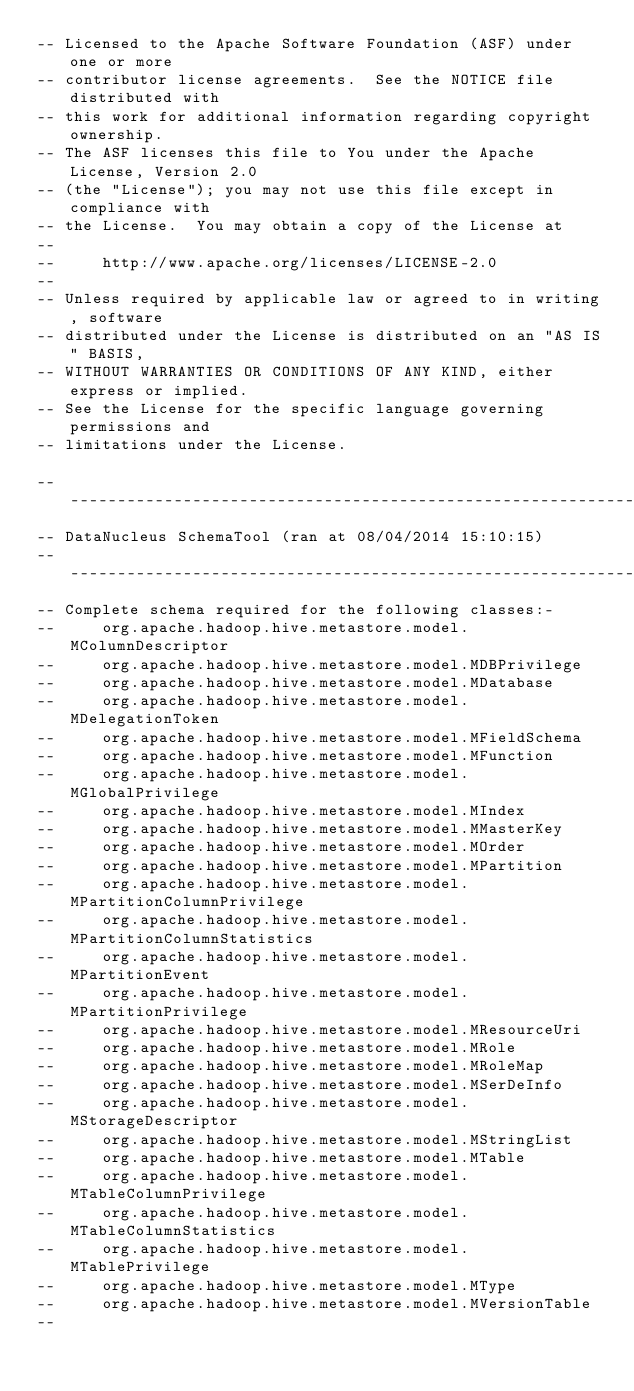Convert code to text. <code><loc_0><loc_0><loc_500><loc_500><_SQL_>-- Licensed to the Apache Software Foundation (ASF) under one or more
-- contributor license agreements.  See the NOTICE file distributed with
-- this work for additional information regarding copyright ownership.
-- The ASF licenses this file to You under the Apache License, Version 2.0
-- (the "License"); you may not use this file except in compliance with
-- the License.  You may obtain a copy of the License at
--
--     http://www.apache.org/licenses/LICENSE-2.0
--
-- Unless required by applicable law or agreed to in writing, software
-- distributed under the License is distributed on an "AS IS" BASIS,
-- WITHOUT WARRANTIES OR CONDITIONS OF ANY KIND, either express or implied.
-- See the License for the specific language governing permissions and
-- limitations under the License.

------------------------------------------------------------------
-- DataNucleus SchemaTool (ran at 08/04/2014 15:10:15)
------------------------------------------------------------------
-- Complete schema required for the following classes:-
--     org.apache.hadoop.hive.metastore.model.MColumnDescriptor
--     org.apache.hadoop.hive.metastore.model.MDBPrivilege
--     org.apache.hadoop.hive.metastore.model.MDatabase
--     org.apache.hadoop.hive.metastore.model.MDelegationToken
--     org.apache.hadoop.hive.metastore.model.MFieldSchema
--     org.apache.hadoop.hive.metastore.model.MFunction
--     org.apache.hadoop.hive.metastore.model.MGlobalPrivilege
--     org.apache.hadoop.hive.metastore.model.MIndex
--     org.apache.hadoop.hive.metastore.model.MMasterKey
--     org.apache.hadoop.hive.metastore.model.MOrder
--     org.apache.hadoop.hive.metastore.model.MPartition
--     org.apache.hadoop.hive.metastore.model.MPartitionColumnPrivilege
--     org.apache.hadoop.hive.metastore.model.MPartitionColumnStatistics
--     org.apache.hadoop.hive.metastore.model.MPartitionEvent
--     org.apache.hadoop.hive.metastore.model.MPartitionPrivilege
--     org.apache.hadoop.hive.metastore.model.MResourceUri
--     org.apache.hadoop.hive.metastore.model.MRole
--     org.apache.hadoop.hive.metastore.model.MRoleMap
--     org.apache.hadoop.hive.metastore.model.MSerDeInfo
--     org.apache.hadoop.hive.metastore.model.MStorageDescriptor
--     org.apache.hadoop.hive.metastore.model.MStringList
--     org.apache.hadoop.hive.metastore.model.MTable
--     org.apache.hadoop.hive.metastore.model.MTableColumnPrivilege
--     org.apache.hadoop.hive.metastore.model.MTableColumnStatistics
--     org.apache.hadoop.hive.metastore.model.MTablePrivilege
--     org.apache.hadoop.hive.metastore.model.MType
--     org.apache.hadoop.hive.metastore.model.MVersionTable
--</code> 